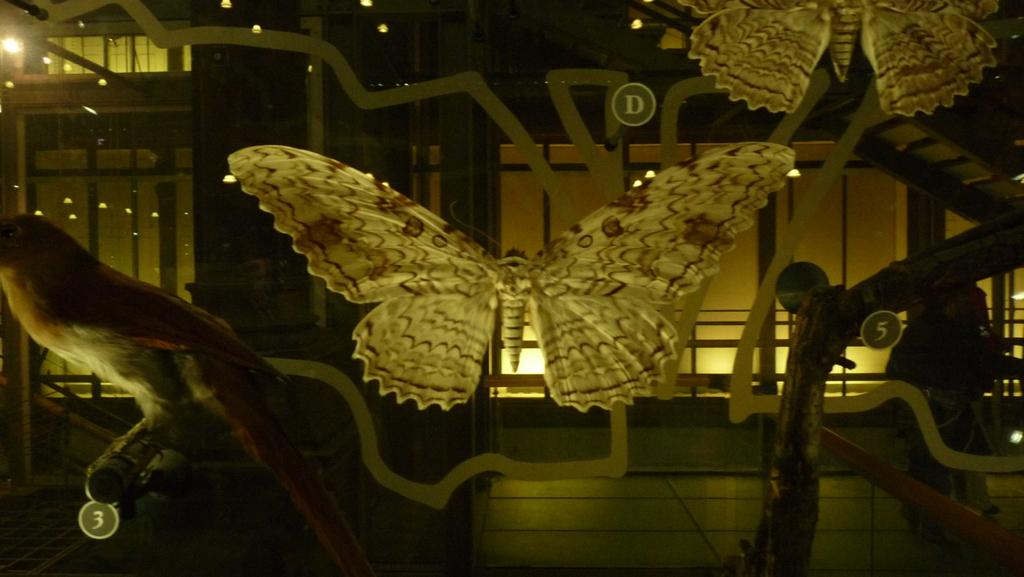What type of toys are present in the image? There are toy butterflies in the image. What other living creature can be seen in the image besides the toy butterflies? There is a bird in the image. Is there a person in the image? Yes, there is a person in the image. What architectural feature is visible in the image? There are stairs in the image. What material is transparent and visible in the image? There is glass visible in the image. What type of illumination is present in the image? There are lights in the image. How many cherries are hanging from the bird's beak in the image? There are no cherries present in the image, and the bird's beak is not shown to be holding any cherries. Can you describe the knot tied by the person in the image? There is no mention of a knot or any activity involving tying a knot in the image. 